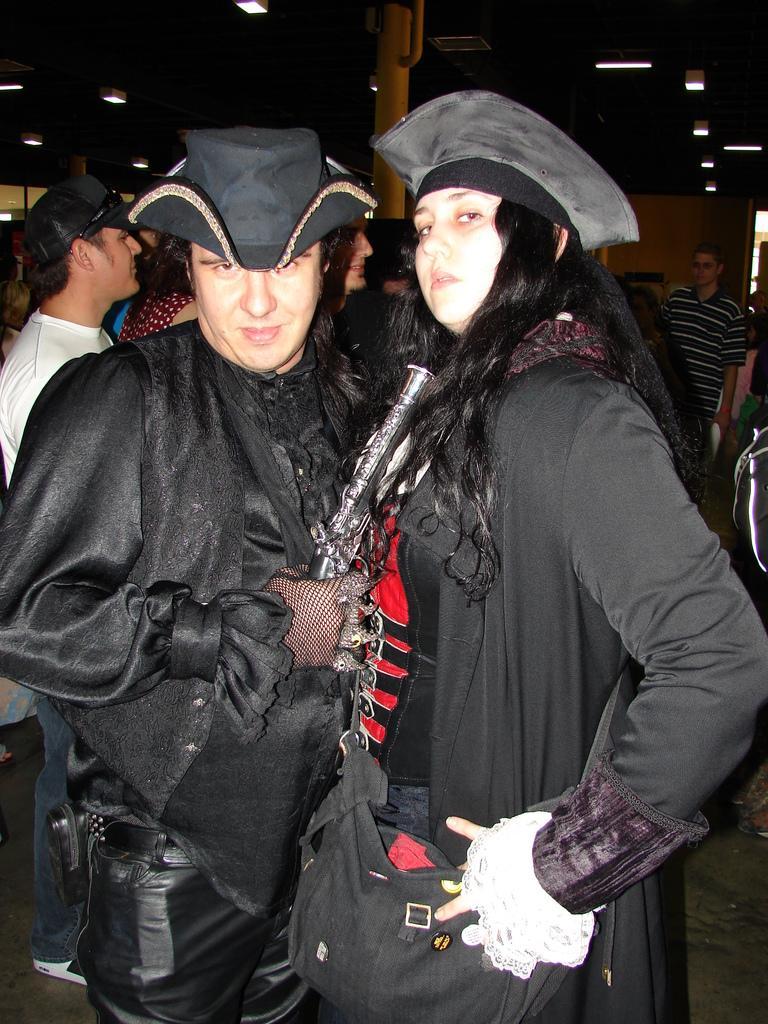Could you give a brief overview of what you see in this image? This picture describes about group of people, in the middle of the given image we can see a man and woman, they wore black color costumes and caps, in the background we can see few lights and a metal rod. 